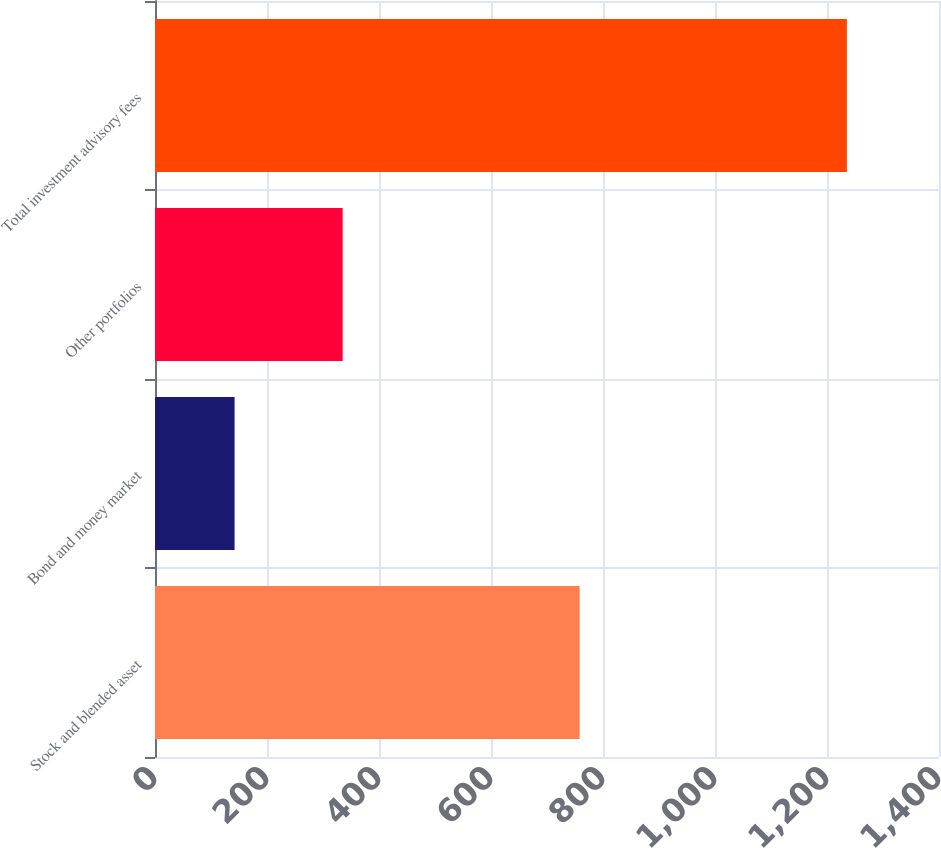<chart> <loc_0><loc_0><loc_500><loc_500><bar_chart><fcel>Stock and blended asset<fcel>Bond and money market<fcel>Other portfolios<fcel>Total investment advisory fees<nl><fcel>758.3<fcel>142.1<fcel>335.1<fcel>1235.5<nl></chart> 